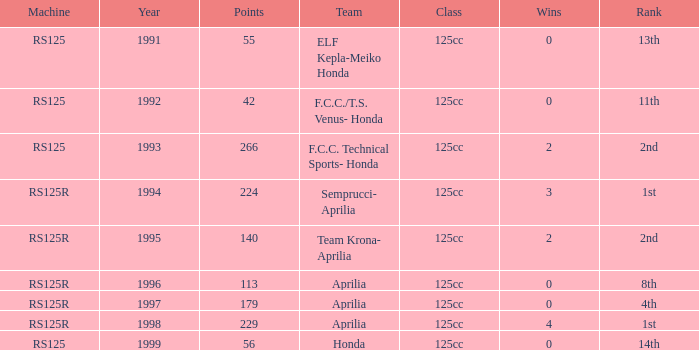Could you parse the entire table as a dict? {'header': ['Machine', 'Year', 'Points', 'Team', 'Class', 'Wins', 'Rank'], 'rows': [['RS125', '1991', '55', 'ELF Kepla-Meiko Honda', '125cc', '0', '13th'], ['RS125', '1992', '42', 'F.C.C./T.S. Venus- Honda', '125cc', '0', '11th'], ['RS125', '1993', '266', 'F.C.C. Technical Sports- Honda', '125cc', '2', '2nd'], ['RS125R', '1994', '224', 'Semprucci- Aprilia', '125cc', '3', '1st'], ['RS125R', '1995', '140', 'Team Krona- Aprilia', '125cc', '2', '2nd'], ['RS125R', '1996', '113', 'Aprilia', '125cc', '0', '8th'], ['RS125R', '1997', '179', 'Aprilia', '125cc', '0', '4th'], ['RS125R', '1998', '229', 'Aprilia', '125cc', '4', '1st'], ['RS125', '1999', '56', 'Honda', '125cc', '0', '14th']]} What year featured an aprilia team with a 4th place standing? 1997.0. 